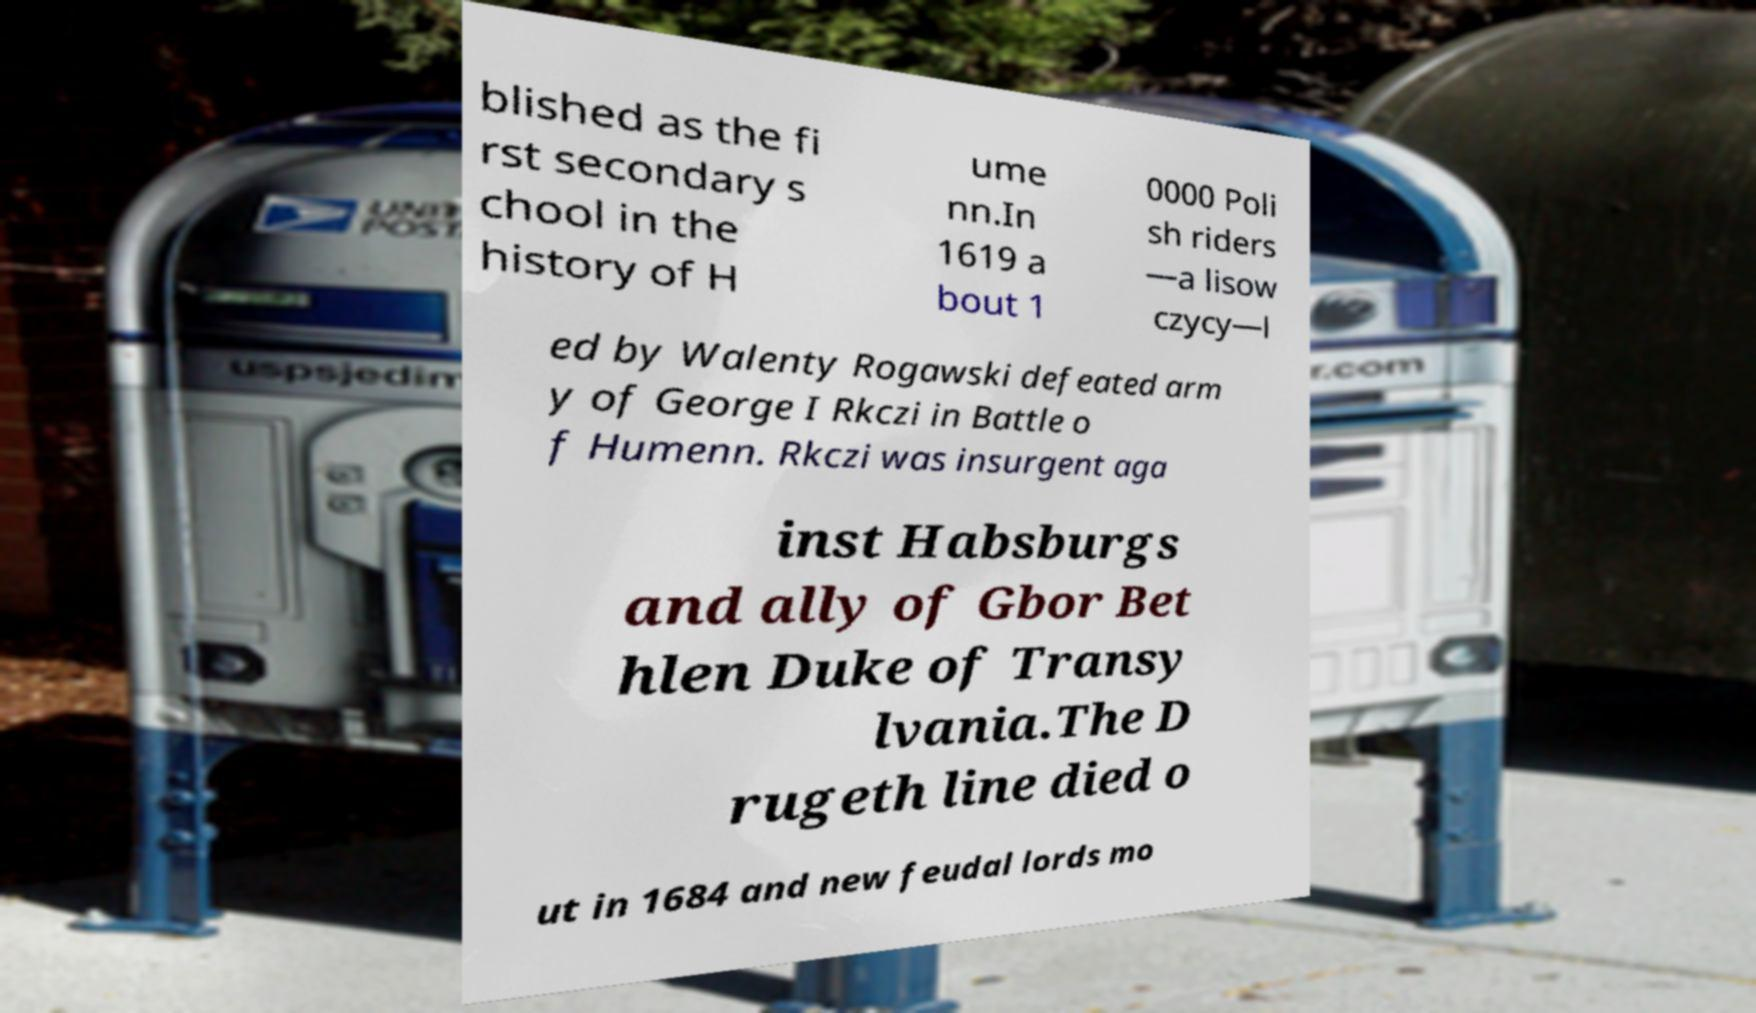What messages or text are displayed in this image? I need them in a readable, typed format. blished as the fi rst secondary s chool in the history of H ume nn.In 1619 a bout 1 0000 Poli sh riders —a lisow czycy—l ed by Walenty Rogawski defeated arm y of George I Rkczi in Battle o f Humenn. Rkczi was insurgent aga inst Habsburgs and ally of Gbor Bet hlen Duke of Transy lvania.The D rugeth line died o ut in 1684 and new feudal lords mo 